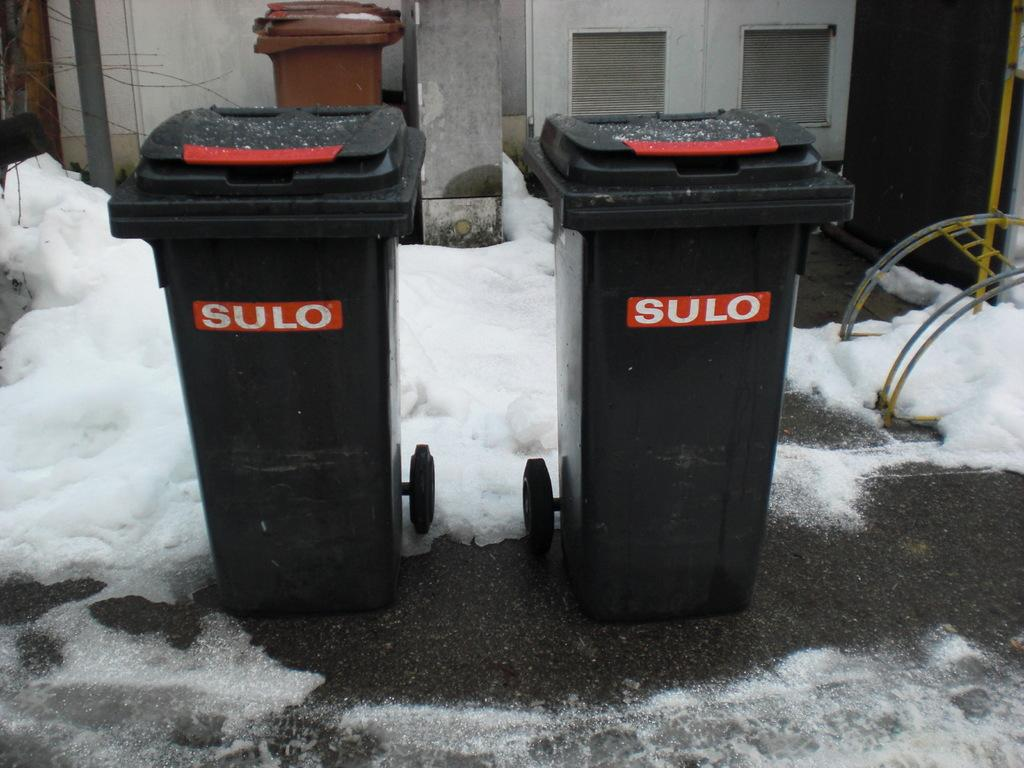<image>
Describe the image concisely. Two Sulo trashcans sitting next to each other outside in the snow. 